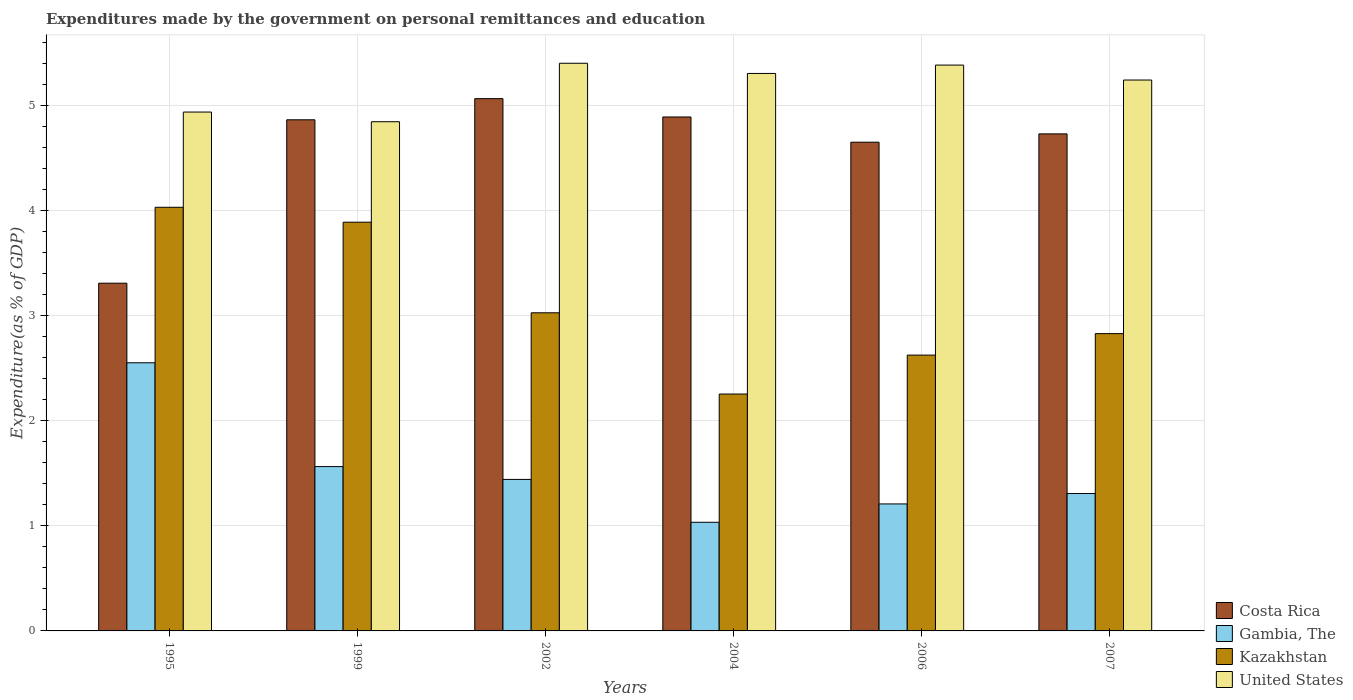How many different coloured bars are there?
Provide a succinct answer. 4. Are the number of bars per tick equal to the number of legend labels?
Offer a terse response. Yes. How many bars are there on the 3rd tick from the left?
Offer a very short reply. 4. What is the expenditures made by the government on personal remittances and education in Costa Rica in 1995?
Provide a short and direct response. 3.31. Across all years, what is the maximum expenditures made by the government on personal remittances and education in Gambia, The?
Give a very brief answer. 2.55. Across all years, what is the minimum expenditures made by the government on personal remittances and education in Gambia, The?
Your answer should be compact. 1.03. In which year was the expenditures made by the government on personal remittances and education in Costa Rica minimum?
Ensure brevity in your answer.  1995. What is the total expenditures made by the government on personal remittances and education in United States in the graph?
Provide a short and direct response. 31.14. What is the difference between the expenditures made by the government on personal remittances and education in United States in 1995 and that in 2007?
Offer a very short reply. -0.3. What is the difference between the expenditures made by the government on personal remittances and education in Kazakhstan in 2007 and the expenditures made by the government on personal remittances and education in United States in 1995?
Provide a short and direct response. -2.11. What is the average expenditures made by the government on personal remittances and education in Kazakhstan per year?
Provide a short and direct response. 3.11. In the year 2006, what is the difference between the expenditures made by the government on personal remittances and education in Kazakhstan and expenditures made by the government on personal remittances and education in Costa Rica?
Keep it short and to the point. -2.03. What is the ratio of the expenditures made by the government on personal remittances and education in United States in 2002 to that in 2007?
Keep it short and to the point. 1.03. What is the difference between the highest and the second highest expenditures made by the government on personal remittances and education in Kazakhstan?
Provide a succinct answer. 0.14. What is the difference between the highest and the lowest expenditures made by the government on personal remittances and education in Kazakhstan?
Provide a succinct answer. 1.78. In how many years, is the expenditures made by the government on personal remittances and education in Gambia, The greater than the average expenditures made by the government on personal remittances and education in Gambia, The taken over all years?
Your answer should be compact. 2. Is it the case that in every year, the sum of the expenditures made by the government on personal remittances and education in Costa Rica and expenditures made by the government on personal remittances and education in Kazakhstan is greater than the sum of expenditures made by the government on personal remittances and education in Gambia, The and expenditures made by the government on personal remittances and education in United States?
Your answer should be compact. No. Is it the case that in every year, the sum of the expenditures made by the government on personal remittances and education in Gambia, The and expenditures made by the government on personal remittances and education in Kazakhstan is greater than the expenditures made by the government on personal remittances and education in Costa Rica?
Your answer should be very brief. No. How many bars are there?
Offer a terse response. 24. What is the difference between two consecutive major ticks on the Y-axis?
Your response must be concise. 1. Does the graph contain grids?
Your answer should be compact. Yes. Where does the legend appear in the graph?
Offer a very short reply. Bottom right. How many legend labels are there?
Offer a terse response. 4. What is the title of the graph?
Your answer should be very brief. Expenditures made by the government on personal remittances and education. What is the label or title of the X-axis?
Your response must be concise. Years. What is the label or title of the Y-axis?
Provide a short and direct response. Expenditure(as % of GDP). What is the Expenditure(as % of GDP) of Costa Rica in 1995?
Your response must be concise. 3.31. What is the Expenditure(as % of GDP) in Gambia, The in 1995?
Give a very brief answer. 2.55. What is the Expenditure(as % of GDP) of Kazakhstan in 1995?
Give a very brief answer. 4.03. What is the Expenditure(as % of GDP) of United States in 1995?
Keep it short and to the point. 4.94. What is the Expenditure(as % of GDP) of Costa Rica in 1999?
Keep it short and to the point. 4.87. What is the Expenditure(as % of GDP) of Gambia, The in 1999?
Your answer should be compact. 1.57. What is the Expenditure(as % of GDP) of Kazakhstan in 1999?
Your response must be concise. 3.89. What is the Expenditure(as % of GDP) in United States in 1999?
Your answer should be compact. 4.85. What is the Expenditure(as % of GDP) in Costa Rica in 2002?
Make the answer very short. 5.07. What is the Expenditure(as % of GDP) in Gambia, The in 2002?
Offer a terse response. 1.44. What is the Expenditure(as % of GDP) in Kazakhstan in 2002?
Provide a short and direct response. 3.03. What is the Expenditure(as % of GDP) of United States in 2002?
Give a very brief answer. 5.41. What is the Expenditure(as % of GDP) of Costa Rica in 2004?
Your answer should be compact. 4.89. What is the Expenditure(as % of GDP) of Gambia, The in 2004?
Your response must be concise. 1.03. What is the Expenditure(as % of GDP) in Kazakhstan in 2004?
Give a very brief answer. 2.26. What is the Expenditure(as % of GDP) in United States in 2004?
Your answer should be very brief. 5.31. What is the Expenditure(as % of GDP) of Costa Rica in 2006?
Keep it short and to the point. 4.65. What is the Expenditure(as % of GDP) in Gambia, The in 2006?
Your answer should be very brief. 1.21. What is the Expenditure(as % of GDP) in Kazakhstan in 2006?
Offer a terse response. 2.63. What is the Expenditure(as % of GDP) of United States in 2006?
Your answer should be very brief. 5.39. What is the Expenditure(as % of GDP) of Costa Rica in 2007?
Give a very brief answer. 4.73. What is the Expenditure(as % of GDP) of Gambia, The in 2007?
Give a very brief answer. 1.31. What is the Expenditure(as % of GDP) in Kazakhstan in 2007?
Offer a terse response. 2.83. What is the Expenditure(as % of GDP) in United States in 2007?
Provide a short and direct response. 5.25. Across all years, what is the maximum Expenditure(as % of GDP) of Costa Rica?
Keep it short and to the point. 5.07. Across all years, what is the maximum Expenditure(as % of GDP) in Gambia, The?
Provide a succinct answer. 2.55. Across all years, what is the maximum Expenditure(as % of GDP) of Kazakhstan?
Give a very brief answer. 4.03. Across all years, what is the maximum Expenditure(as % of GDP) of United States?
Your answer should be very brief. 5.41. Across all years, what is the minimum Expenditure(as % of GDP) in Costa Rica?
Ensure brevity in your answer.  3.31. Across all years, what is the minimum Expenditure(as % of GDP) in Gambia, The?
Your response must be concise. 1.03. Across all years, what is the minimum Expenditure(as % of GDP) in Kazakhstan?
Provide a short and direct response. 2.26. Across all years, what is the minimum Expenditure(as % of GDP) in United States?
Provide a succinct answer. 4.85. What is the total Expenditure(as % of GDP) in Costa Rica in the graph?
Your answer should be compact. 27.53. What is the total Expenditure(as % of GDP) of Gambia, The in the graph?
Ensure brevity in your answer.  9.11. What is the total Expenditure(as % of GDP) of Kazakhstan in the graph?
Ensure brevity in your answer.  18.67. What is the total Expenditure(as % of GDP) of United States in the graph?
Ensure brevity in your answer.  31.14. What is the difference between the Expenditure(as % of GDP) of Costa Rica in 1995 and that in 1999?
Your answer should be compact. -1.56. What is the difference between the Expenditure(as % of GDP) in Gambia, The in 1995 and that in 1999?
Offer a terse response. 0.99. What is the difference between the Expenditure(as % of GDP) in Kazakhstan in 1995 and that in 1999?
Offer a very short reply. 0.14. What is the difference between the Expenditure(as % of GDP) in United States in 1995 and that in 1999?
Ensure brevity in your answer.  0.09. What is the difference between the Expenditure(as % of GDP) of Costa Rica in 1995 and that in 2002?
Provide a short and direct response. -1.76. What is the difference between the Expenditure(as % of GDP) of Gambia, The in 1995 and that in 2002?
Your response must be concise. 1.11. What is the difference between the Expenditure(as % of GDP) in Kazakhstan in 1995 and that in 2002?
Your response must be concise. 1. What is the difference between the Expenditure(as % of GDP) in United States in 1995 and that in 2002?
Offer a terse response. -0.46. What is the difference between the Expenditure(as % of GDP) of Costa Rica in 1995 and that in 2004?
Offer a very short reply. -1.58. What is the difference between the Expenditure(as % of GDP) of Gambia, The in 1995 and that in 2004?
Make the answer very short. 1.52. What is the difference between the Expenditure(as % of GDP) in Kazakhstan in 1995 and that in 2004?
Provide a short and direct response. 1.78. What is the difference between the Expenditure(as % of GDP) in United States in 1995 and that in 2004?
Provide a succinct answer. -0.37. What is the difference between the Expenditure(as % of GDP) in Costa Rica in 1995 and that in 2006?
Provide a short and direct response. -1.34. What is the difference between the Expenditure(as % of GDP) of Gambia, The in 1995 and that in 2006?
Ensure brevity in your answer.  1.34. What is the difference between the Expenditure(as % of GDP) in Kazakhstan in 1995 and that in 2006?
Ensure brevity in your answer.  1.41. What is the difference between the Expenditure(as % of GDP) of United States in 1995 and that in 2006?
Keep it short and to the point. -0.45. What is the difference between the Expenditure(as % of GDP) of Costa Rica in 1995 and that in 2007?
Your answer should be very brief. -1.42. What is the difference between the Expenditure(as % of GDP) in Gambia, The in 1995 and that in 2007?
Make the answer very short. 1.25. What is the difference between the Expenditure(as % of GDP) in Kazakhstan in 1995 and that in 2007?
Provide a short and direct response. 1.2. What is the difference between the Expenditure(as % of GDP) in United States in 1995 and that in 2007?
Offer a very short reply. -0.3. What is the difference between the Expenditure(as % of GDP) of Costa Rica in 1999 and that in 2002?
Offer a very short reply. -0.2. What is the difference between the Expenditure(as % of GDP) of Gambia, The in 1999 and that in 2002?
Your answer should be compact. 0.12. What is the difference between the Expenditure(as % of GDP) of Kazakhstan in 1999 and that in 2002?
Keep it short and to the point. 0.86. What is the difference between the Expenditure(as % of GDP) of United States in 1999 and that in 2002?
Your answer should be very brief. -0.56. What is the difference between the Expenditure(as % of GDP) in Costa Rica in 1999 and that in 2004?
Keep it short and to the point. -0.03. What is the difference between the Expenditure(as % of GDP) in Gambia, The in 1999 and that in 2004?
Give a very brief answer. 0.53. What is the difference between the Expenditure(as % of GDP) of Kazakhstan in 1999 and that in 2004?
Keep it short and to the point. 1.64. What is the difference between the Expenditure(as % of GDP) in United States in 1999 and that in 2004?
Provide a succinct answer. -0.46. What is the difference between the Expenditure(as % of GDP) in Costa Rica in 1999 and that in 2006?
Your answer should be compact. 0.21. What is the difference between the Expenditure(as % of GDP) of Gambia, The in 1999 and that in 2006?
Keep it short and to the point. 0.36. What is the difference between the Expenditure(as % of GDP) in Kazakhstan in 1999 and that in 2006?
Your answer should be compact. 1.27. What is the difference between the Expenditure(as % of GDP) in United States in 1999 and that in 2006?
Give a very brief answer. -0.54. What is the difference between the Expenditure(as % of GDP) in Costa Rica in 1999 and that in 2007?
Offer a terse response. 0.13. What is the difference between the Expenditure(as % of GDP) in Gambia, The in 1999 and that in 2007?
Provide a short and direct response. 0.26. What is the difference between the Expenditure(as % of GDP) of Kazakhstan in 1999 and that in 2007?
Make the answer very short. 1.06. What is the difference between the Expenditure(as % of GDP) of United States in 1999 and that in 2007?
Offer a very short reply. -0.4. What is the difference between the Expenditure(as % of GDP) of Costa Rica in 2002 and that in 2004?
Your answer should be compact. 0.17. What is the difference between the Expenditure(as % of GDP) of Gambia, The in 2002 and that in 2004?
Your answer should be very brief. 0.41. What is the difference between the Expenditure(as % of GDP) in Kazakhstan in 2002 and that in 2004?
Offer a terse response. 0.77. What is the difference between the Expenditure(as % of GDP) of United States in 2002 and that in 2004?
Your response must be concise. 0.1. What is the difference between the Expenditure(as % of GDP) of Costa Rica in 2002 and that in 2006?
Make the answer very short. 0.41. What is the difference between the Expenditure(as % of GDP) in Gambia, The in 2002 and that in 2006?
Make the answer very short. 0.23. What is the difference between the Expenditure(as % of GDP) in Kazakhstan in 2002 and that in 2006?
Your answer should be very brief. 0.4. What is the difference between the Expenditure(as % of GDP) of United States in 2002 and that in 2006?
Your answer should be very brief. 0.02. What is the difference between the Expenditure(as % of GDP) in Costa Rica in 2002 and that in 2007?
Provide a short and direct response. 0.34. What is the difference between the Expenditure(as % of GDP) of Gambia, The in 2002 and that in 2007?
Your answer should be compact. 0.13. What is the difference between the Expenditure(as % of GDP) of Kazakhstan in 2002 and that in 2007?
Keep it short and to the point. 0.2. What is the difference between the Expenditure(as % of GDP) in United States in 2002 and that in 2007?
Give a very brief answer. 0.16. What is the difference between the Expenditure(as % of GDP) in Costa Rica in 2004 and that in 2006?
Ensure brevity in your answer.  0.24. What is the difference between the Expenditure(as % of GDP) in Gambia, The in 2004 and that in 2006?
Give a very brief answer. -0.17. What is the difference between the Expenditure(as % of GDP) in Kazakhstan in 2004 and that in 2006?
Provide a short and direct response. -0.37. What is the difference between the Expenditure(as % of GDP) in United States in 2004 and that in 2006?
Keep it short and to the point. -0.08. What is the difference between the Expenditure(as % of GDP) of Costa Rica in 2004 and that in 2007?
Your answer should be very brief. 0.16. What is the difference between the Expenditure(as % of GDP) in Gambia, The in 2004 and that in 2007?
Your answer should be compact. -0.27. What is the difference between the Expenditure(as % of GDP) of Kazakhstan in 2004 and that in 2007?
Your answer should be very brief. -0.58. What is the difference between the Expenditure(as % of GDP) in United States in 2004 and that in 2007?
Make the answer very short. 0.06. What is the difference between the Expenditure(as % of GDP) of Costa Rica in 2006 and that in 2007?
Ensure brevity in your answer.  -0.08. What is the difference between the Expenditure(as % of GDP) in Gambia, The in 2006 and that in 2007?
Ensure brevity in your answer.  -0.1. What is the difference between the Expenditure(as % of GDP) in Kazakhstan in 2006 and that in 2007?
Keep it short and to the point. -0.2. What is the difference between the Expenditure(as % of GDP) in United States in 2006 and that in 2007?
Your answer should be very brief. 0.14. What is the difference between the Expenditure(as % of GDP) in Costa Rica in 1995 and the Expenditure(as % of GDP) in Gambia, The in 1999?
Make the answer very short. 1.75. What is the difference between the Expenditure(as % of GDP) in Costa Rica in 1995 and the Expenditure(as % of GDP) in Kazakhstan in 1999?
Provide a succinct answer. -0.58. What is the difference between the Expenditure(as % of GDP) in Costa Rica in 1995 and the Expenditure(as % of GDP) in United States in 1999?
Make the answer very short. -1.54. What is the difference between the Expenditure(as % of GDP) of Gambia, The in 1995 and the Expenditure(as % of GDP) of Kazakhstan in 1999?
Offer a very short reply. -1.34. What is the difference between the Expenditure(as % of GDP) in Gambia, The in 1995 and the Expenditure(as % of GDP) in United States in 1999?
Make the answer very short. -2.3. What is the difference between the Expenditure(as % of GDP) of Kazakhstan in 1995 and the Expenditure(as % of GDP) of United States in 1999?
Offer a very short reply. -0.81. What is the difference between the Expenditure(as % of GDP) of Costa Rica in 1995 and the Expenditure(as % of GDP) of Gambia, The in 2002?
Your answer should be compact. 1.87. What is the difference between the Expenditure(as % of GDP) of Costa Rica in 1995 and the Expenditure(as % of GDP) of Kazakhstan in 2002?
Your response must be concise. 0.28. What is the difference between the Expenditure(as % of GDP) of Costa Rica in 1995 and the Expenditure(as % of GDP) of United States in 2002?
Provide a succinct answer. -2.09. What is the difference between the Expenditure(as % of GDP) of Gambia, The in 1995 and the Expenditure(as % of GDP) of Kazakhstan in 2002?
Your answer should be compact. -0.48. What is the difference between the Expenditure(as % of GDP) of Gambia, The in 1995 and the Expenditure(as % of GDP) of United States in 2002?
Give a very brief answer. -2.85. What is the difference between the Expenditure(as % of GDP) of Kazakhstan in 1995 and the Expenditure(as % of GDP) of United States in 2002?
Your answer should be compact. -1.37. What is the difference between the Expenditure(as % of GDP) of Costa Rica in 1995 and the Expenditure(as % of GDP) of Gambia, The in 2004?
Keep it short and to the point. 2.28. What is the difference between the Expenditure(as % of GDP) in Costa Rica in 1995 and the Expenditure(as % of GDP) in Kazakhstan in 2004?
Offer a very short reply. 1.06. What is the difference between the Expenditure(as % of GDP) of Costa Rica in 1995 and the Expenditure(as % of GDP) of United States in 2004?
Keep it short and to the point. -2. What is the difference between the Expenditure(as % of GDP) in Gambia, The in 1995 and the Expenditure(as % of GDP) in Kazakhstan in 2004?
Your response must be concise. 0.3. What is the difference between the Expenditure(as % of GDP) in Gambia, The in 1995 and the Expenditure(as % of GDP) in United States in 2004?
Keep it short and to the point. -2.76. What is the difference between the Expenditure(as % of GDP) of Kazakhstan in 1995 and the Expenditure(as % of GDP) of United States in 2004?
Provide a succinct answer. -1.27. What is the difference between the Expenditure(as % of GDP) of Costa Rica in 1995 and the Expenditure(as % of GDP) of Gambia, The in 2006?
Offer a very short reply. 2.1. What is the difference between the Expenditure(as % of GDP) in Costa Rica in 1995 and the Expenditure(as % of GDP) in Kazakhstan in 2006?
Ensure brevity in your answer.  0.68. What is the difference between the Expenditure(as % of GDP) of Costa Rica in 1995 and the Expenditure(as % of GDP) of United States in 2006?
Offer a terse response. -2.08. What is the difference between the Expenditure(as % of GDP) in Gambia, The in 1995 and the Expenditure(as % of GDP) in Kazakhstan in 2006?
Your answer should be very brief. -0.07. What is the difference between the Expenditure(as % of GDP) in Gambia, The in 1995 and the Expenditure(as % of GDP) in United States in 2006?
Your answer should be compact. -2.84. What is the difference between the Expenditure(as % of GDP) of Kazakhstan in 1995 and the Expenditure(as % of GDP) of United States in 2006?
Offer a very short reply. -1.35. What is the difference between the Expenditure(as % of GDP) in Costa Rica in 1995 and the Expenditure(as % of GDP) in Gambia, The in 2007?
Your answer should be compact. 2. What is the difference between the Expenditure(as % of GDP) of Costa Rica in 1995 and the Expenditure(as % of GDP) of Kazakhstan in 2007?
Ensure brevity in your answer.  0.48. What is the difference between the Expenditure(as % of GDP) of Costa Rica in 1995 and the Expenditure(as % of GDP) of United States in 2007?
Ensure brevity in your answer.  -1.93. What is the difference between the Expenditure(as % of GDP) in Gambia, The in 1995 and the Expenditure(as % of GDP) in Kazakhstan in 2007?
Make the answer very short. -0.28. What is the difference between the Expenditure(as % of GDP) of Gambia, The in 1995 and the Expenditure(as % of GDP) of United States in 2007?
Your answer should be compact. -2.69. What is the difference between the Expenditure(as % of GDP) in Kazakhstan in 1995 and the Expenditure(as % of GDP) in United States in 2007?
Your answer should be very brief. -1.21. What is the difference between the Expenditure(as % of GDP) of Costa Rica in 1999 and the Expenditure(as % of GDP) of Gambia, The in 2002?
Keep it short and to the point. 3.42. What is the difference between the Expenditure(as % of GDP) of Costa Rica in 1999 and the Expenditure(as % of GDP) of Kazakhstan in 2002?
Ensure brevity in your answer.  1.84. What is the difference between the Expenditure(as % of GDP) of Costa Rica in 1999 and the Expenditure(as % of GDP) of United States in 2002?
Your answer should be very brief. -0.54. What is the difference between the Expenditure(as % of GDP) of Gambia, The in 1999 and the Expenditure(as % of GDP) of Kazakhstan in 2002?
Your answer should be compact. -1.46. What is the difference between the Expenditure(as % of GDP) in Gambia, The in 1999 and the Expenditure(as % of GDP) in United States in 2002?
Keep it short and to the point. -3.84. What is the difference between the Expenditure(as % of GDP) in Kazakhstan in 1999 and the Expenditure(as % of GDP) in United States in 2002?
Give a very brief answer. -1.51. What is the difference between the Expenditure(as % of GDP) in Costa Rica in 1999 and the Expenditure(as % of GDP) in Gambia, The in 2004?
Offer a very short reply. 3.83. What is the difference between the Expenditure(as % of GDP) in Costa Rica in 1999 and the Expenditure(as % of GDP) in Kazakhstan in 2004?
Provide a succinct answer. 2.61. What is the difference between the Expenditure(as % of GDP) of Costa Rica in 1999 and the Expenditure(as % of GDP) of United States in 2004?
Provide a succinct answer. -0.44. What is the difference between the Expenditure(as % of GDP) of Gambia, The in 1999 and the Expenditure(as % of GDP) of Kazakhstan in 2004?
Make the answer very short. -0.69. What is the difference between the Expenditure(as % of GDP) of Gambia, The in 1999 and the Expenditure(as % of GDP) of United States in 2004?
Give a very brief answer. -3.74. What is the difference between the Expenditure(as % of GDP) of Kazakhstan in 1999 and the Expenditure(as % of GDP) of United States in 2004?
Offer a very short reply. -1.42. What is the difference between the Expenditure(as % of GDP) in Costa Rica in 1999 and the Expenditure(as % of GDP) in Gambia, The in 2006?
Offer a terse response. 3.66. What is the difference between the Expenditure(as % of GDP) of Costa Rica in 1999 and the Expenditure(as % of GDP) of Kazakhstan in 2006?
Offer a very short reply. 2.24. What is the difference between the Expenditure(as % of GDP) of Costa Rica in 1999 and the Expenditure(as % of GDP) of United States in 2006?
Offer a terse response. -0.52. What is the difference between the Expenditure(as % of GDP) of Gambia, The in 1999 and the Expenditure(as % of GDP) of Kazakhstan in 2006?
Give a very brief answer. -1.06. What is the difference between the Expenditure(as % of GDP) of Gambia, The in 1999 and the Expenditure(as % of GDP) of United States in 2006?
Make the answer very short. -3.82. What is the difference between the Expenditure(as % of GDP) of Kazakhstan in 1999 and the Expenditure(as % of GDP) of United States in 2006?
Keep it short and to the point. -1.5. What is the difference between the Expenditure(as % of GDP) of Costa Rica in 1999 and the Expenditure(as % of GDP) of Gambia, The in 2007?
Give a very brief answer. 3.56. What is the difference between the Expenditure(as % of GDP) in Costa Rica in 1999 and the Expenditure(as % of GDP) in Kazakhstan in 2007?
Give a very brief answer. 2.04. What is the difference between the Expenditure(as % of GDP) in Costa Rica in 1999 and the Expenditure(as % of GDP) in United States in 2007?
Keep it short and to the point. -0.38. What is the difference between the Expenditure(as % of GDP) of Gambia, The in 1999 and the Expenditure(as % of GDP) of Kazakhstan in 2007?
Your response must be concise. -1.27. What is the difference between the Expenditure(as % of GDP) of Gambia, The in 1999 and the Expenditure(as % of GDP) of United States in 2007?
Provide a succinct answer. -3.68. What is the difference between the Expenditure(as % of GDP) in Kazakhstan in 1999 and the Expenditure(as % of GDP) in United States in 2007?
Offer a terse response. -1.35. What is the difference between the Expenditure(as % of GDP) in Costa Rica in 2002 and the Expenditure(as % of GDP) in Gambia, The in 2004?
Provide a succinct answer. 4.03. What is the difference between the Expenditure(as % of GDP) of Costa Rica in 2002 and the Expenditure(as % of GDP) of Kazakhstan in 2004?
Your answer should be compact. 2.81. What is the difference between the Expenditure(as % of GDP) in Costa Rica in 2002 and the Expenditure(as % of GDP) in United States in 2004?
Ensure brevity in your answer.  -0.24. What is the difference between the Expenditure(as % of GDP) of Gambia, The in 2002 and the Expenditure(as % of GDP) of Kazakhstan in 2004?
Your response must be concise. -0.81. What is the difference between the Expenditure(as % of GDP) of Gambia, The in 2002 and the Expenditure(as % of GDP) of United States in 2004?
Keep it short and to the point. -3.87. What is the difference between the Expenditure(as % of GDP) in Kazakhstan in 2002 and the Expenditure(as % of GDP) in United States in 2004?
Your response must be concise. -2.28. What is the difference between the Expenditure(as % of GDP) of Costa Rica in 2002 and the Expenditure(as % of GDP) of Gambia, The in 2006?
Your answer should be compact. 3.86. What is the difference between the Expenditure(as % of GDP) in Costa Rica in 2002 and the Expenditure(as % of GDP) in Kazakhstan in 2006?
Your answer should be very brief. 2.44. What is the difference between the Expenditure(as % of GDP) in Costa Rica in 2002 and the Expenditure(as % of GDP) in United States in 2006?
Your answer should be very brief. -0.32. What is the difference between the Expenditure(as % of GDP) in Gambia, The in 2002 and the Expenditure(as % of GDP) in Kazakhstan in 2006?
Ensure brevity in your answer.  -1.18. What is the difference between the Expenditure(as % of GDP) in Gambia, The in 2002 and the Expenditure(as % of GDP) in United States in 2006?
Give a very brief answer. -3.95. What is the difference between the Expenditure(as % of GDP) in Kazakhstan in 2002 and the Expenditure(as % of GDP) in United States in 2006?
Your answer should be very brief. -2.36. What is the difference between the Expenditure(as % of GDP) in Costa Rica in 2002 and the Expenditure(as % of GDP) in Gambia, The in 2007?
Offer a very short reply. 3.76. What is the difference between the Expenditure(as % of GDP) in Costa Rica in 2002 and the Expenditure(as % of GDP) in Kazakhstan in 2007?
Your answer should be very brief. 2.24. What is the difference between the Expenditure(as % of GDP) in Costa Rica in 2002 and the Expenditure(as % of GDP) in United States in 2007?
Make the answer very short. -0.18. What is the difference between the Expenditure(as % of GDP) of Gambia, The in 2002 and the Expenditure(as % of GDP) of Kazakhstan in 2007?
Offer a very short reply. -1.39. What is the difference between the Expenditure(as % of GDP) of Gambia, The in 2002 and the Expenditure(as % of GDP) of United States in 2007?
Your answer should be compact. -3.8. What is the difference between the Expenditure(as % of GDP) of Kazakhstan in 2002 and the Expenditure(as % of GDP) of United States in 2007?
Your response must be concise. -2.22. What is the difference between the Expenditure(as % of GDP) of Costa Rica in 2004 and the Expenditure(as % of GDP) of Gambia, The in 2006?
Provide a succinct answer. 3.69. What is the difference between the Expenditure(as % of GDP) of Costa Rica in 2004 and the Expenditure(as % of GDP) of Kazakhstan in 2006?
Provide a short and direct response. 2.27. What is the difference between the Expenditure(as % of GDP) in Costa Rica in 2004 and the Expenditure(as % of GDP) in United States in 2006?
Your response must be concise. -0.49. What is the difference between the Expenditure(as % of GDP) of Gambia, The in 2004 and the Expenditure(as % of GDP) of Kazakhstan in 2006?
Your answer should be very brief. -1.59. What is the difference between the Expenditure(as % of GDP) of Gambia, The in 2004 and the Expenditure(as % of GDP) of United States in 2006?
Offer a very short reply. -4.35. What is the difference between the Expenditure(as % of GDP) in Kazakhstan in 2004 and the Expenditure(as % of GDP) in United States in 2006?
Provide a short and direct response. -3.13. What is the difference between the Expenditure(as % of GDP) of Costa Rica in 2004 and the Expenditure(as % of GDP) of Gambia, The in 2007?
Your answer should be compact. 3.59. What is the difference between the Expenditure(as % of GDP) in Costa Rica in 2004 and the Expenditure(as % of GDP) in Kazakhstan in 2007?
Offer a very short reply. 2.06. What is the difference between the Expenditure(as % of GDP) in Costa Rica in 2004 and the Expenditure(as % of GDP) in United States in 2007?
Your answer should be very brief. -0.35. What is the difference between the Expenditure(as % of GDP) in Gambia, The in 2004 and the Expenditure(as % of GDP) in Kazakhstan in 2007?
Give a very brief answer. -1.8. What is the difference between the Expenditure(as % of GDP) in Gambia, The in 2004 and the Expenditure(as % of GDP) in United States in 2007?
Offer a very short reply. -4.21. What is the difference between the Expenditure(as % of GDP) in Kazakhstan in 2004 and the Expenditure(as % of GDP) in United States in 2007?
Your response must be concise. -2.99. What is the difference between the Expenditure(as % of GDP) of Costa Rica in 2006 and the Expenditure(as % of GDP) of Gambia, The in 2007?
Provide a succinct answer. 3.35. What is the difference between the Expenditure(as % of GDP) of Costa Rica in 2006 and the Expenditure(as % of GDP) of Kazakhstan in 2007?
Your answer should be very brief. 1.82. What is the difference between the Expenditure(as % of GDP) in Costa Rica in 2006 and the Expenditure(as % of GDP) in United States in 2007?
Keep it short and to the point. -0.59. What is the difference between the Expenditure(as % of GDP) of Gambia, The in 2006 and the Expenditure(as % of GDP) of Kazakhstan in 2007?
Make the answer very short. -1.62. What is the difference between the Expenditure(as % of GDP) in Gambia, The in 2006 and the Expenditure(as % of GDP) in United States in 2007?
Provide a short and direct response. -4.04. What is the difference between the Expenditure(as % of GDP) in Kazakhstan in 2006 and the Expenditure(as % of GDP) in United States in 2007?
Your response must be concise. -2.62. What is the average Expenditure(as % of GDP) of Costa Rica per year?
Keep it short and to the point. 4.59. What is the average Expenditure(as % of GDP) in Gambia, The per year?
Your answer should be very brief. 1.52. What is the average Expenditure(as % of GDP) in Kazakhstan per year?
Give a very brief answer. 3.11. What is the average Expenditure(as % of GDP) of United States per year?
Provide a succinct answer. 5.19. In the year 1995, what is the difference between the Expenditure(as % of GDP) of Costa Rica and Expenditure(as % of GDP) of Gambia, The?
Provide a short and direct response. 0.76. In the year 1995, what is the difference between the Expenditure(as % of GDP) of Costa Rica and Expenditure(as % of GDP) of Kazakhstan?
Keep it short and to the point. -0.72. In the year 1995, what is the difference between the Expenditure(as % of GDP) of Costa Rica and Expenditure(as % of GDP) of United States?
Keep it short and to the point. -1.63. In the year 1995, what is the difference between the Expenditure(as % of GDP) in Gambia, The and Expenditure(as % of GDP) in Kazakhstan?
Offer a very short reply. -1.48. In the year 1995, what is the difference between the Expenditure(as % of GDP) of Gambia, The and Expenditure(as % of GDP) of United States?
Your answer should be compact. -2.39. In the year 1995, what is the difference between the Expenditure(as % of GDP) of Kazakhstan and Expenditure(as % of GDP) of United States?
Ensure brevity in your answer.  -0.91. In the year 1999, what is the difference between the Expenditure(as % of GDP) of Costa Rica and Expenditure(as % of GDP) of Gambia, The?
Offer a terse response. 3.3. In the year 1999, what is the difference between the Expenditure(as % of GDP) in Costa Rica and Expenditure(as % of GDP) in Kazakhstan?
Your answer should be very brief. 0.98. In the year 1999, what is the difference between the Expenditure(as % of GDP) in Costa Rica and Expenditure(as % of GDP) in United States?
Offer a terse response. 0.02. In the year 1999, what is the difference between the Expenditure(as % of GDP) in Gambia, The and Expenditure(as % of GDP) in Kazakhstan?
Provide a succinct answer. -2.33. In the year 1999, what is the difference between the Expenditure(as % of GDP) of Gambia, The and Expenditure(as % of GDP) of United States?
Make the answer very short. -3.28. In the year 1999, what is the difference between the Expenditure(as % of GDP) in Kazakhstan and Expenditure(as % of GDP) in United States?
Provide a short and direct response. -0.96. In the year 2002, what is the difference between the Expenditure(as % of GDP) of Costa Rica and Expenditure(as % of GDP) of Gambia, The?
Ensure brevity in your answer.  3.63. In the year 2002, what is the difference between the Expenditure(as % of GDP) in Costa Rica and Expenditure(as % of GDP) in Kazakhstan?
Provide a succinct answer. 2.04. In the year 2002, what is the difference between the Expenditure(as % of GDP) of Costa Rica and Expenditure(as % of GDP) of United States?
Provide a succinct answer. -0.34. In the year 2002, what is the difference between the Expenditure(as % of GDP) of Gambia, The and Expenditure(as % of GDP) of Kazakhstan?
Your answer should be very brief. -1.59. In the year 2002, what is the difference between the Expenditure(as % of GDP) of Gambia, The and Expenditure(as % of GDP) of United States?
Keep it short and to the point. -3.96. In the year 2002, what is the difference between the Expenditure(as % of GDP) of Kazakhstan and Expenditure(as % of GDP) of United States?
Provide a short and direct response. -2.38. In the year 2004, what is the difference between the Expenditure(as % of GDP) in Costa Rica and Expenditure(as % of GDP) in Gambia, The?
Ensure brevity in your answer.  3.86. In the year 2004, what is the difference between the Expenditure(as % of GDP) in Costa Rica and Expenditure(as % of GDP) in Kazakhstan?
Make the answer very short. 2.64. In the year 2004, what is the difference between the Expenditure(as % of GDP) in Costa Rica and Expenditure(as % of GDP) in United States?
Provide a short and direct response. -0.41. In the year 2004, what is the difference between the Expenditure(as % of GDP) of Gambia, The and Expenditure(as % of GDP) of Kazakhstan?
Your answer should be compact. -1.22. In the year 2004, what is the difference between the Expenditure(as % of GDP) in Gambia, The and Expenditure(as % of GDP) in United States?
Keep it short and to the point. -4.27. In the year 2004, what is the difference between the Expenditure(as % of GDP) in Kazakhstan and Expenditure(as % of GDP) in United States?
Keep it short and to the point. -3.05. In the year 2006, what is the difference between the Expenditure(as % of GDP) of Costa Rica and Expenditure(as % of GDP) of Gambia, The?
Your response must be concise. 3.44. In the year 2006, what is the difference between the Expenditure(as % of GDP) in Costa Rica and Expenditure(as % of GDP) in Kazakhstan?
Offer a terse response. 2.03. In the year 2006, what is the difference between the Expenditure(as % of GDP) in Costa Rica and Expenditure(as % of GDP) in United States?
Keep it short and to the point. -0.73. In the year 2006, what is the difference between the Expenditure(as % of GDP) of Gambia, The and Expenditure(as % of GDP) of Kazakhstan?
Make the answer very short. -1.42. In the year 2006, what is the difference between the Expenditure(as % of GDP) in Gambia, The and Expenditure(as % of GDP) in United States?
Keep it short and to the point. -4.18. In the year 2006, what is the difference between the Expenditure(as % of GDP) in Kazakhstan and Expenditure(as % of GDP) in United States?
Your response must be concise. -2.76. In the year 2007, what is the difference between the Expenditure(as % of GDP) in Costa Rica and Expenditure(as % of GDP) in Gambia, The?
Your response must be concise. 3.43. In the year 2007, what is the difference between the Expenditure(as % of GDP) of Costa Rica and Expenditure(as % of GDP) of Kazakhstan?
Make the answer very short. 1.9. In the year 2007, what is the difference between the Expenditure(as % of GDP) in Costa Rica and Expenditure(as % of GDP) in United States?
Offer a very short reply. -0.51. In the year 2007, what is the difference between the Expenditure(as % of GDP) of Gambia, The and Expenditure(as % of GDP) of Kazakhstan?
Offer a very short reply. -1.52. In the year 2007, what is the difference between the Expenditure(as % of GDP) in Gambia, The and Expenditure(as % of GDP) in United States?
Keep it short and to the point. -3.94. In the year 2007, what is the difference between the Expenditure(as % of GDP) of Kazakhstan and Expenditure(as % of GDP) of United States?
Ensure brevity in your answer.  -2.42. What is the ratio of the Expenditure(as % of GDP) in Costa Rica in 1995 to that in 1999?
Provide a short and direct response. 0.68. What is the ratio of the Expenditure(as % of GDP) of Gambia, The in 1995 to that in 1999?
Provide a succinct answer. 1.63. What is the ratio of the Expenditure(as % of GDP) in Kazakhstan in 1995 to that in 1999?
Ensure brevity in your answer.  1.04. What is the ratio of the Expenditure(as % of GDP) of United States in 1995 to that in 1999?
Give a very brief answer. 1.02. What is the ratio of the Expenditure(as % of GDP) in Costa Rica in 1995 to that in 2002?
Provide a succinct answer. 0.65. What is the ratio of the Expenditure(as % of GDP) in Gambia, The in 1995 to that in 2002?
Ensure brevity in your answer.  1.77. What is the ratio of the Expenditure(as % of GDP) in Kazakhstan in 1995 to that in 2002?
Offer a terse response. 1.33. What is the ratio of the Expenditure(as % of GDP) in United States in 1995 to that in 2002?
Make the answer very short. 0.91. What is the ratio of the Expenditure(as % of GDP) of Costa Rica in 1995 to that in 2004?
Ensure brevity in your answer.  0.68. What is the ratio of the Expenditure(as % of GDP) in Gambia, The in 1995 to that in 2004?
Provide a short and direct response. 2.47. What is the ratio of the Expenditure(as % of GDP) of Kazakhstan in 1995 to that in 2004?
Offer a very short reply. 1.79. What is the ratio of the Expenditure(as % of GDP) of United States in 1995 to that in 2004?
Your answer should be compact. 0.93. What is the ratio of the Expenditure(as % of GDP) of Costa Rica in 1995 to that in 2006?
Give a very brief answer. 0.71. What is the ratio of the Expenditure(as % of GDP) in Gambia, The in 1995 to that in 2006?
Make the answer very short. 2.11. What is the ratio of the Expenditure(as % of GDP) of Kazakhstan in 1995 to that in 2006?
Your answer should be compact. 1.54. What is the ratio of the Expenditure(as % of GDP) of United States in 1995 to that in 2006?
Make the answer very short. 0.92. What is the ratio of the Expenditure(as % of GDP) in Costa Rica in 1995 to that in 2007?
Make the answer very short. 0.7. What is the ratio of the Expenditure(as % of GDP) in Gambia, The in 1995 to that in 2007?
Your response must be concise. 1.95. What is the ratio of the Expenditure(as % of GDP) in Kazakhstan in 1995 to that in 2007?
Ensure brevity in your answer.  1.42. What is the ratio of the Expenditure(as % of GDP) in United States in 1995 to that in 2007?
Give a very brief answer. 0.94. What is the ratio of the Expenditure(as % of GDP) in Costa Rica in 1999 to that in 2002?
Offer a very short reply. 0.96. What is the ratio of the Expenditure(as % of GDP) of Gambia, The in 1999 to that in 2002?
Give a very brief answer. 1.08. What is the ratio of the Expenditure(as % of GDP) of Kazakhstan in 1999 to that in 2002?
Provide a succinct answer. 1.28. What is the ratio of the Expenditure(as % of GDP) in United States in 1999 to that in 2002?
Keep it short and to the point. 0.9. What is the ratio of the Expenditure(as % of GDP) of Gambia, The in 1999 to that in 2004?
Offer a terse response. 1.51. What is the ratio of the Expenditure(as % of GDP) of Kazakhstan in 1999 to that in 2004?
Provide a succinct answer. 1.73. What is the ratio of the Expenditure(as % of GDP) of United States in 1999 to that in 2004?
Provide a succinct answer. 0.91. What is the ratio of the Expenditure(as % of GDP) of Costa Rica in 1999 to that in 2006?
Offer a very short reply. 1.05. What is the ratio of the Expenditure(as % of GDP) in Gambia, The in 1999 to that in 2006?
Provide a succinct answer. 1.29. What is the ratio of the Expenditure(as % of GDP) of Kazakhstan in 1999 to that in 2006?
Ensure brevity in your answer.  1.48. What is the ratio of the Expenditure(as % of GDP) of United States in 1999 to that in 2006?
Your response must be concise. 0.9. What is the ratio of the Expenditure(as % of GDP) of Costa Rica in 1999 to that in 2007?
Give a very brief answer. 1.03. What is the ratio of the Expenditure(as % of GDP) of Gambia, The in 1999 to that in 2007?
Ensure brevity in your answer.  1.2. What is the ratio of the Expenditure(as % of GDP) in Kazakhstan in 1999 to that in 2007?
Give a very brief answer. 1.37. What is the ratio of the Expenditure(as % of GDP) of United States in 1999 to that in 2007?
Provide a succinct answer. 0.92. What is the ratio of the Expenditure(as % of GDP) of Costa Rica in 2002 to that in 2004?
Offer a terse response. 1.04. What is the ratio of the Expenditure(as % of GDP) of Gambia, The in 2002 to that in 2004?
Your answer should be very brief. 1.39. What is the ratio of the Expenditure(as % of GDP) of Kazakhstan in 2002 to that in 2004?
Give a very brief answer. 1.34. What is the ratio of the Expenditure(as % of GDP) in United States in 2002 to that in 2004?
Offer a very short reply. 1.02. What is the ratio of the Expenditure(as % of GDP) in Costa Rica in 2002 to that in 2006?
Ensure brevity in your answer.  1.09. What is the ratio of the Expenditure(as % of GDP) of Gambia, The in 2002 to that in 2006?
Offer a very short reply. 1.19. What is the ratio of the Expenditure(as % of GDP) of Kazakhstan in 2002 to that in 2006?
Offer a very short reply. 1.15. What is the ratio of the Expenditure(as % of GDP) in Costa Rica in 2002 to that in 2007?
Offer a terse response. 1.07. What is the ratio of the Expenditure(as % of GDP) in Gambia, The in 2002 to that in 2007?
Keep it short and to the point. 1.1. What is the ratio of the Expenditure(as % of GDP) in Kazakhstan in 2002 to that in 2007?
Your answer should be very brief. 1.07. What is the ratio of the Expenditure(as % of GDP) of United States in 2002 to that in 2007?
Provide a succinct answer. 1.03. What is the ratio of the Expenditure(as % of GDP) of Costa Rica in 2004 to that in 2006?
Offer a very short reply. 1.05. What is the ratio of the Expenditure(as % of GDP) of Gambia, The in 2004 to that in 2006?
Ensure brevity in your answer.  0.86. What is the ratio of the Expenditure(as % of GDP) of Kazakhstan in 2004 to that in 2006?
Your answer should be very brief. 0.86. What is the ratio of the Expenditure(as % of GDP) of United States in 2004 to that in 2006?
Make the answer very short. 0.99. What is the ratio of the Expenditure(as % of GDP) of Costa Rica in 2004 to that in 2007?
Provide a short and direct response. 1.03. What is the ratio of the Expenditure(as % of GDP) in Gambia, The in 2004 to that in 2007?
Offer a terse response. 0.79. What is the ratio of the Expenditure(as % of GDP) in Kazakhstan in 2004 to that in 2007?
Make the answer very short. 0.8. What is the ratio of the Expenditure(as % of GDP) of United States in 2004 to that in 2007?
Offer a very short reply. 1.01. What is the ratio of the Expenditure(as % of GDP) of Costa Rica in 2006 to that in 2007?
Give a very brief answer. 0.98. What is the ratio of the Expenditure(as % of GDP) in Gambia, The in 2006 to that in 2007?
Make the answer very short. 0.92. What is the ratio of the Expenditure(as % of GDP) of Kazakhstan in 2006 to that in 2007?
Offer a very short reply. 0.93. What is the ratio of the Expenditure(as % of GDP) of United States in 2006 to that in 2007?
Provide a short and direct response. 1.03. What is the difference between the highest and the second highest Expenditure(as % of GDP) in Costa Rica?
Your response must be concise. 0.17. What is the difference between the highest and the second highest Expenditure(as % of GDP) in Gambia, The?
Provide a succinct answer. 0.99. What is the difference between the highest and the second highest Expenditure(as % of GDP) in Kazakhstan?
Offer a very short reply. 0.14. What is the difference between the highest and the second highest Expenditure(as % of GDP) in United States?
Provide a succinct answer. 0.02. What is the difference between the highest and the lowest Expenditure(as % of GDP) of Costa Rica?
Your answer should be very brief. 1.76. What is the difference between the highest and the lowest Expenditure(as % of GDP) of Gambia, The?
Provide a short and direct response. 1.52. What is the difference between the highest and the lowest Expenditure(as % of GDP) of Kazakhstan?
Your answer should be very brief. 1.78. What is the difference between the highest and the lowest Expenditure(as % of GDP) of United States?
Offer a terse response. 0.56. 